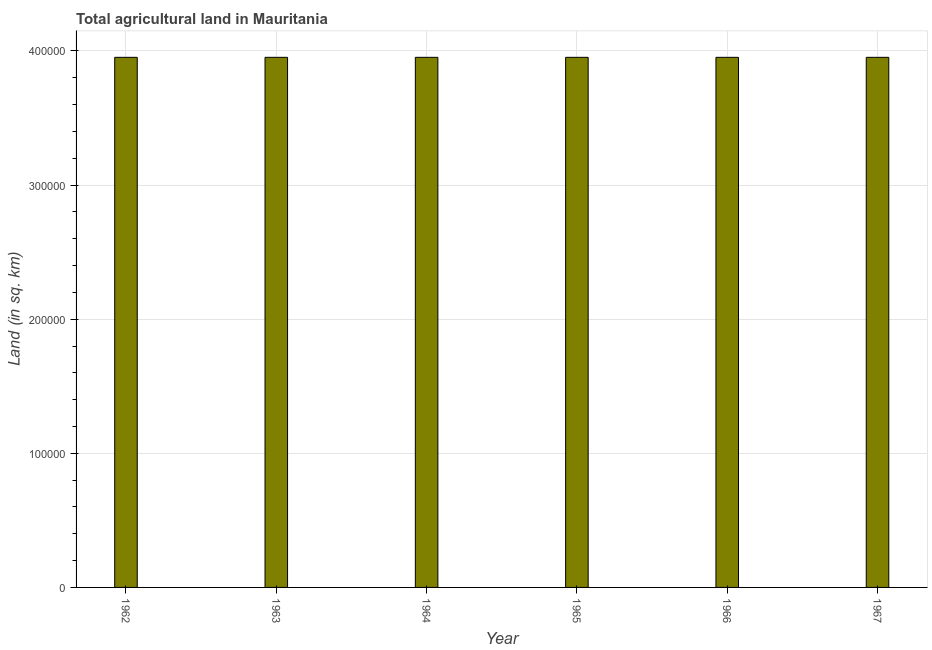Does the graph contain grids?
Provide a succinct answer. Yes. What is the title of the graph?
Provide a short and direct response. Total agricultural land in Mauritania. What is the label or title of the Y-axis?
Make the answer very short. Land (in sq. km). What is the agricultural land in 1967?
Ensure brevity in your answer.  3.95e+05. Across all years, what is the maximum agricultural land?
Make the answer very short. 3.95e+05. Across all years, what is the minimum agricultural land?
Make the answer very short. 3.95e+05. What is the sum of the agricultural land?
Give a very brief answer. 2.37e+06. What is the average agricultural land per year?
Your answer should be very brief. 3.95e+05. What is the median agricultural land?
Your answer should be compact. 3.95e+05. In how many years, is the agricultural land greater than 140000 sq. km?
Offer a very short reply. 6. Is the difference between the agricultural land in 1964 and 1967 greater than the difference between any two years?
Ensure brevity in your answer.  No. In how many years, is the agricultural land greater than the average agricultural land taken over all years?
Your answer should be compact. 5. How many years are there in the graph?
Offer a terse response. 6. What is the difference between two consecutive major ticks on the Y-axis?
Give a very brief answer. 1.00e+05. Are the values on the major ticks of Y-axis written in scientific E-notation?
Your answer should be very brief. No. What is the Land (in sq. km) of 1962?
Make the answer very short. 3.95e+05. What is the Land (in sq. km) of 1963?
Make the answer very short. 3.95e+05. What is the Land (in sq. km) in 1964?
Offer a very short reply. 3.95e+05. What is the Land (in sq. km) in 1965?
Your answer should be compact. 3.95e+05. What is the Land (in sq. km) of 1966?
Provide a short and direct response. 3.95e+05. What is the Land (in sq. km) in 1967?
Offer a terse response. 3.95e+05. What is the difference between the Land (in sq. km) in 1962 and 1964?
Offer a very short reply. -10. What is the difference between the Land (in sq. km) in 1962 and 1966?
Make the answer very short. -10. What is the difference between the Land (in sq. km) in 1963 and 1966?
Ensure brevity in your answer.  0. What is the difference between the Land (in sq. km) in 1965 and 1966?
Keep it short and to the point. 0. What is the difference between the Land (in sq. km) in 1966 and 1967?
Ensure brevity in your answer.  0. What is the ratio of the Land (in sq. km) in 1962 to that in 1964?
Provide a succinct answer. 1. What is the ratio of the Land (in sq. km) in 1962 to that in 1965?
Offer a terse response. 1. What is the ratio of the Land (in sq. km) in 1962 to that in 1966?
Ensure brevity in your answer.  1. What is the ratio of the Land (in sq. km) in 1963 to that in 1964?
Make the answer very short. 1. What is the ratio of the Land (in sq. km) in 1963 to that in 1965?
Keep it short and to the point. 1. What is the ratio of the Land (in sq. km) in 1963 to that in 1967?
Your answer should be very brief. 1. What is the ratio of the Land (in sq. km) in 1964 to that in 1966?
Provide a succinct answer. 1. What is the ratio of the Land (in sq. km) in 1965 to that in 1966?
Your response must be concise. 1. What is the ratio of the Land (in sq. km) in 1965 to that in 1967?
Ensure brevity in your answer.  1. 